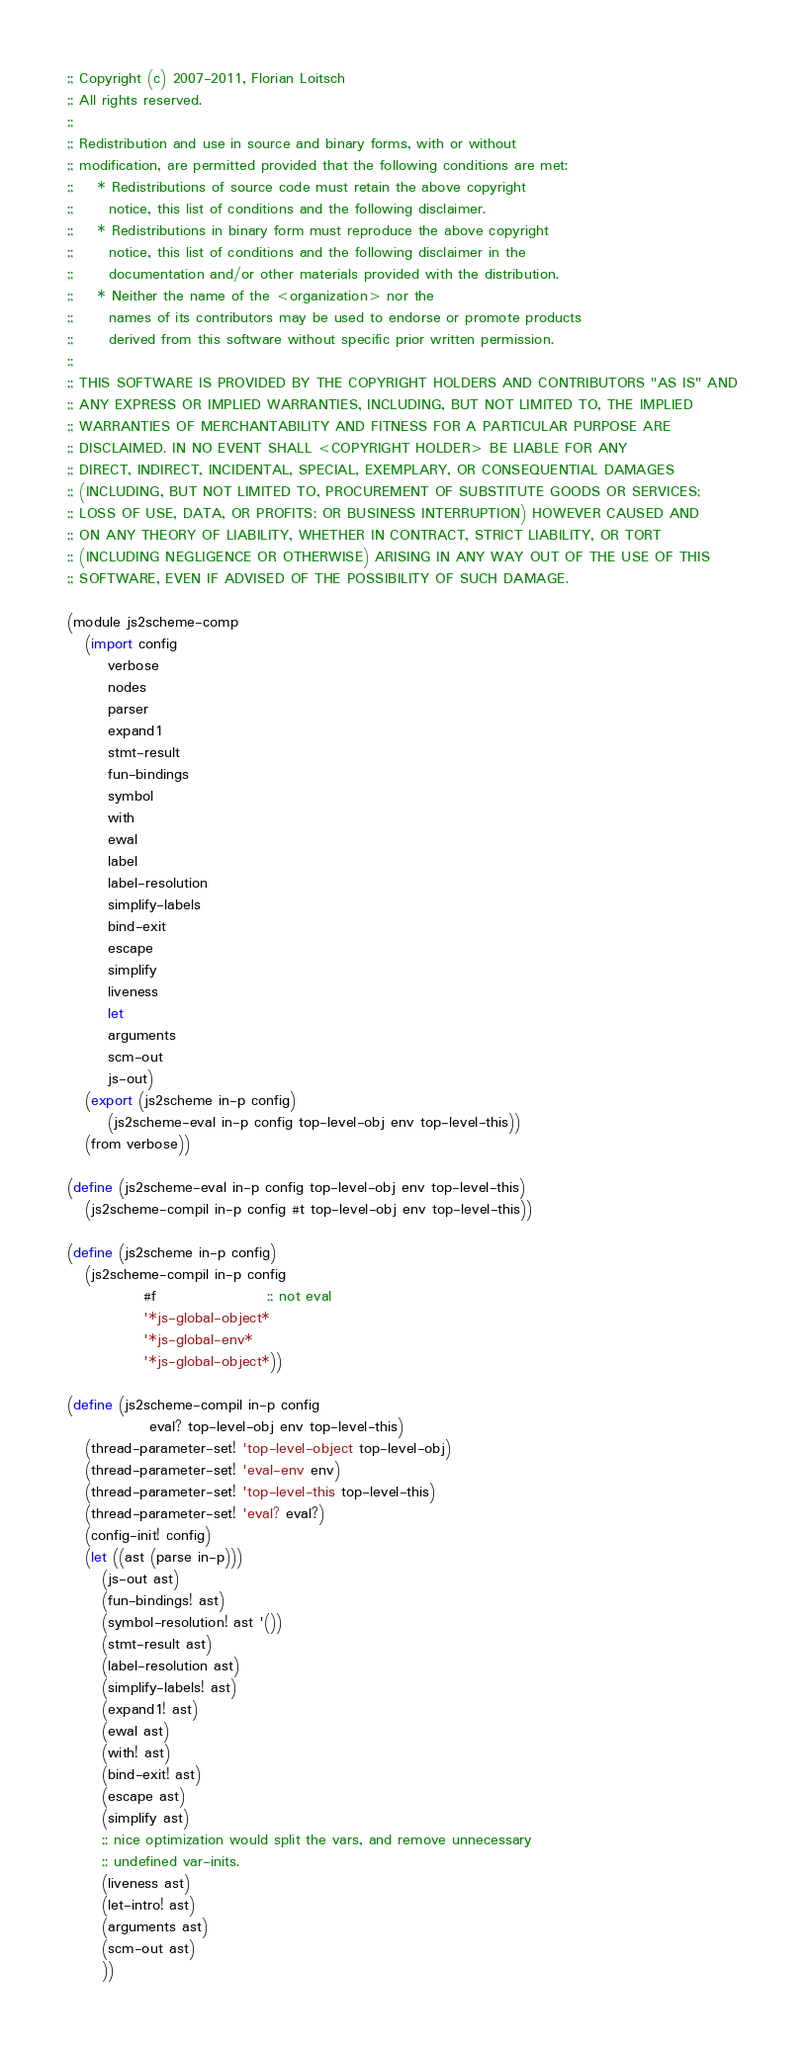Convert code to text. <code><loc_0><loc_0><loc_500><loc_500><_Scheme_>;; Copyright (c) 2007-2011, Florian Loitsch
;; All rights reserved.
;;
;; Redistribution and use in source and binary forms, with or without
;; modification, are permitted provided that the following conditions are met:
;;    * Redistributions of source code must retain the above copyright
;;      notice, this list of conditions and the following disclaimer.
;;    * Redistributions in binary form must reproduce the above copyright
;;      notice, this list of conditions and the following disclaimer in the
;;      documentation and/or other materials provided with the distribution.
;;    * Neither the name of the <organization> nor the
;;      names of its contributors may be used to endorse or promote products
;;      derived from this software without specific prior written permission.
;;
;; THIS SOFTWARE IS PROVIDED BY THE COPYRIGHT HOLDERS AND CONTRIBUTORS "AS IS" AND
;; ANY EXPRESS OR IMPLIED WARRANTIES, INCLUDING, BUT NOT LIMITED TO, THE IMPLIED
;; WARRANTIES OF MERCHANTABILITY AND FITNESS FOR A PARTICULAR PURPOSE ARE
;; DISCLAIMED. IN NO EVENT SHALL <COPYRIGHT HOLDER> BE LIABLE FOR ANY
;; DIRECT, INDIRECT, INCIDENTAL, SPECIAL, EXEMPLARY, OR CONSEQUENTIAL DAMAGES
;; (INCLUDING, BUT NOT LIMITED TO, PROCUREMENT OF SUBSTITUTE GOODS OR SERVICES;
;; LOSS OF USE, DATA, OR PROFITS; OR BUSINESS INTERRUPTION) HOWEVER CAUSED AND
;; ON ANY THEORY OF LIABILITY, WHETHER IN CONTRACT, STRICT LIABILITY, OR TORT
;; (INCLUDING NEGLIGENCE OR OTHERWISE) ARISING IN ANY WAY OUT OF THE USE OF THIS
;; SOFTWARE, EVEN IF ADVISED OF THE POSSIBILITY OF SUCH DAMAGE.

(module js2scheme-comp
   (import config
	   verbose
	   nodes
	   parser
	   expand1
	   stmt-result
	   fun-bindings
	   symbol
	   with
	   ewal
	   label
	   label-resolution
	   simplify-labels
	   bind-exit
	   escape
	   simplify
	   liveness
	   let
	   arguments
	   scm-out
	   js-out)
   (export (js2scheme in-p config)
	   (js2scheme-eval in-p config top-level-obj env top-level-this))
   (from verbose))

(define (js2scheme-eval in-p config top-level-obj env top-level-this)
   (js2scheme-compil in-p config #t top-level-obj env top-level-this))

(define (js2scheme in-p config)
   (js2scheme-compil in-p config
		     #f                   ;; not eval
		     '*js-global-object*
		     '*js-global-env*
		     '*js-global-object*))

(define (js2scheme-compil in-p config
			  eval? top-level-obj env top-level-this)
   (thread-parameter-set! 'top-level-object top-level-obj)
   (thread-parameter-set! 'eval-env env)
   (thread-parameter-set! 'top-level-this top-level-this)
   (thread-parameter-set! 'eval? eval?)
   (config-init! config)
   (let ((ast (parse in-p)))
      (js-out ast)
      (fun-bindings! ast)
      (symbol-resolution! ast '())
      (stmt-result ast)
      (label-resolution ast)
      (simplify-labels! ast)
      (expand1! ast)
      (ewal ast)
      (with! ast)
      (bind-exit! ast)
      (escape ast)
      (simplify ast)
      ;; nice optimization would split the vars, and remove unnecessary
      ;; undefined var-inits.
      (liveness ast)
      (let-intro! ast)
      (arguments ast)
      (scm-out ast)
      ))
</code> 